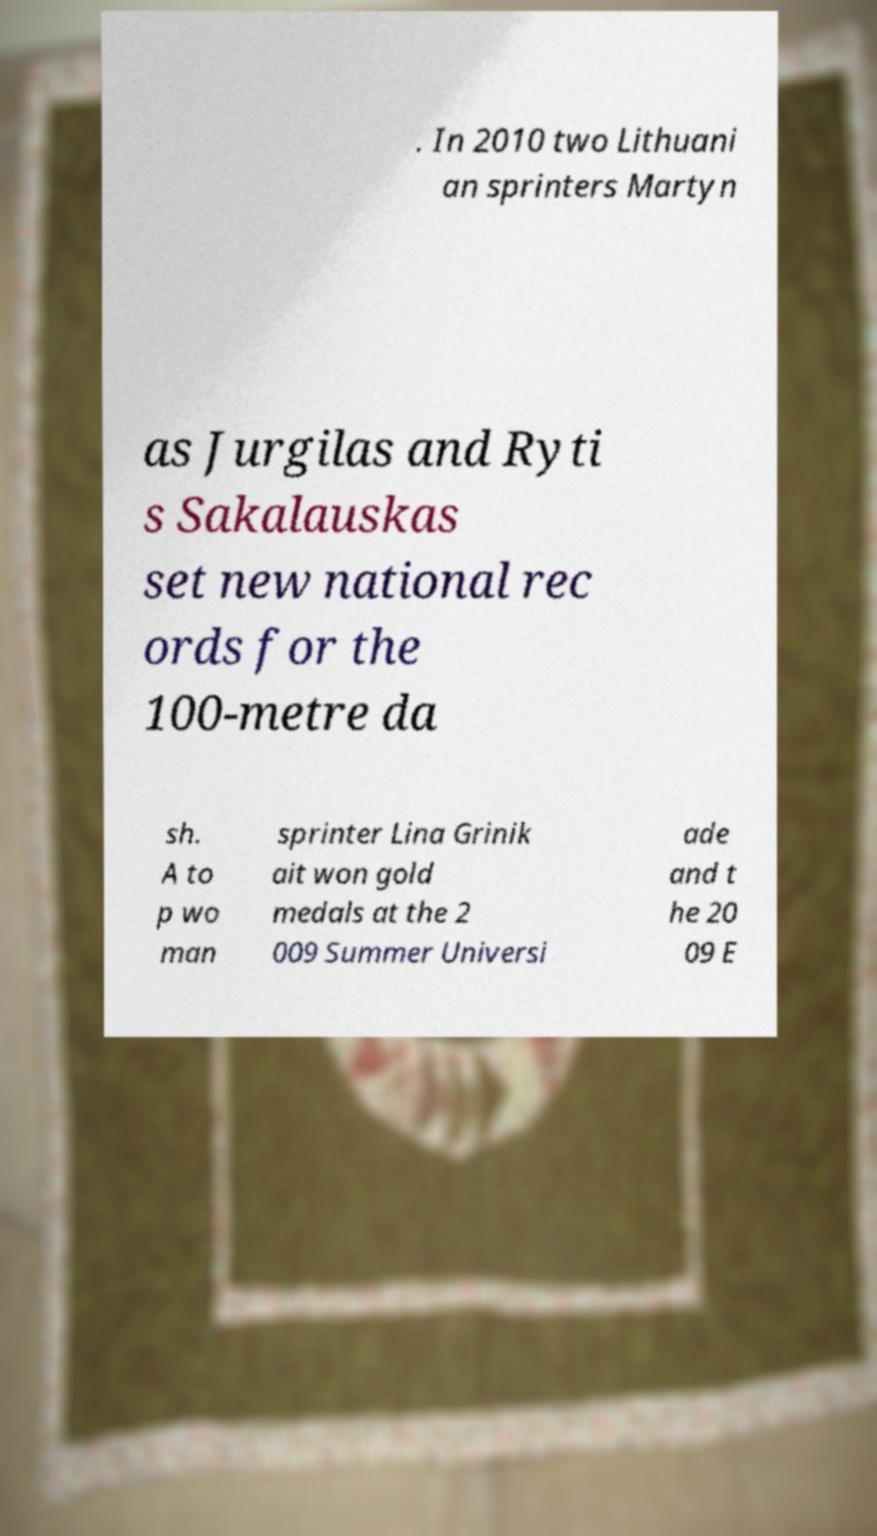For documentation purposes, I need the text within this image transcribed. Could you provide that? . In 2010 two Lithuani an sprinters Martyn as Jurgilas and Ryti s Sakalauskas set new national rec ords for the 100-metre da sh. A to p wo man sprinter Lina Grinik ait won gold medals at the 2 009 Summer Universi ade and t he 20 09 E 